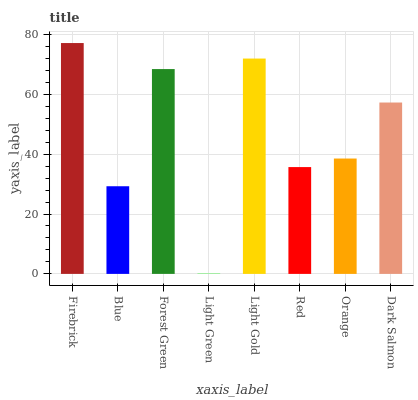Is Blue the minimum?
Answer yes or no. No. Is Blue the maximum?
Answer yes or no. No. Is Firebrick greater than Blue?
Answer yes or no. Yes. Is Blue less than Firebrick?
Answer yes or no. Yes. Is Blue greater than Firebrick?
Answer yes or no. No. Is Firebrick less than Blue?
Answer yes or no. No. Is Dark Salmon the high median?
Answer yes or no. Yes. Is Orange the low median?
Answer yes or no. Yes. Is Light Gold the high median?
Answer yes or no. No. Is Blue the low median?
Answer yes or no. No. 